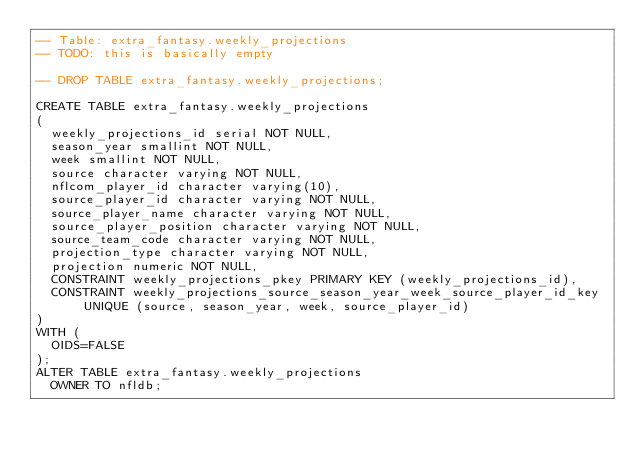<code> <loc_0><loc_0><loc_500><loc_500><_SQL_>-- Table: extra_fantasy.weekly_projections
-- TODO: this is basically empty

-- DROP TABLE extra_fantasy.weekly_projections;

CREATE TABLE extra_fantasy.weekly_projections
(
  weekly_projections_id serial NOT NULL,
  season_year smallint NOT NULL,
  week smallint NOT NULL,
  source character varying NOT NULL,
  nflcom_player_id character varying(10),
  source_player_id character varying NOT NULL,
  source_player_name character varying NOT NULL,
  source_player_position character varying NOT NULL,
  source_team_code character varying NOT NULL,
  projection_type character varying NOT NULL,
  projection numeric NOT NULL,
  CONSTRAINT weekly_projections_pkey PRIMARY KEY (weekly_projections_id),
  CONSTRAINT weekly_projections_source_season_year_week_source_player_id_key UNIQUE (source, season_year, week, source_player_id)
)
WITH (
  OIDS=FALSE
);
ALTER TABLE extra_fantasy.weekly_projections
  OWNER TO nfldb;
</code> 